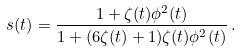<formula> <loc_0><loc_0><loc_500><loc_500>s ( t ) = \frac { 1 + \zeta ( t ) \phi ^ { 2 } ( t ) } { 1 + ( 6 \zeta ( t ) + 1 ) \zeta ( t ) \phi ^ { 2 } ( t ) } \, .</formula> 